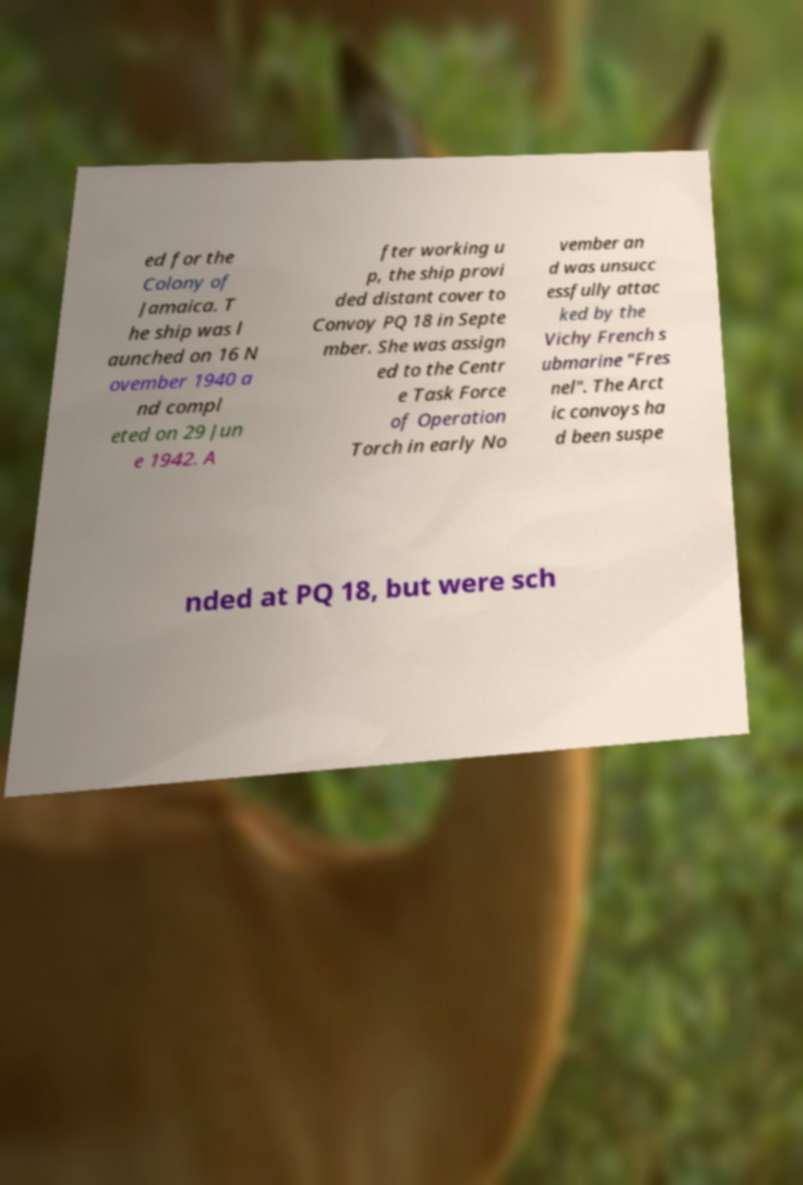What messages or text are displayed in this image? I need them in a readable, typed format. ed for the Colony of Jamaica. T he ship was l aunched on 16 N ovember 1940 a nd compl eted on 29 Jun e 1942. A fter working u p, the ship provi ded distant cover to Convoy PQ 18 in Septe mber. She was assign ed to the Centr e Task Force of Operation Torch in early No vember an d was unsucc essfully attac ked by the Vichy French s ubmarine "Fres nel". The Arct ic convoys ha d been suspe nded at PQ 18, but were sch 